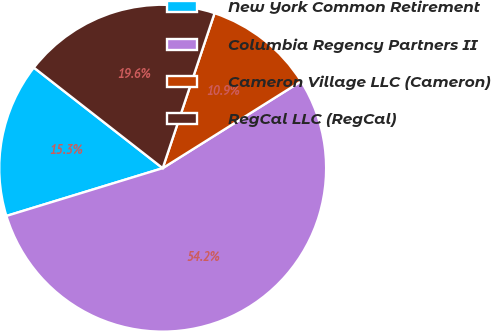<chart> <loc_0><loc_0><loc_500><loc_500><pie_chart><fcel>New York Common Retirement<fcel>Columbia Regency Partners II<fcel>Cameron Village LLC (Cameron)<fcel>RegCal LLC (RegCal)<nl><fcel>15.27%<fcel>54.2%<fcel>10.94%<fcel>19.59%<nl></chart> 